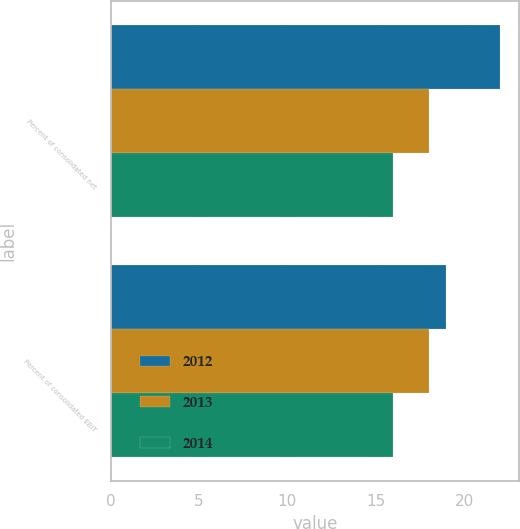<chart> <loc_0><loc_0><loc_500><loc_500><stacked_bar_chart><ecel><fcel>Percent of consolidated net<fcel>Percent of consolidated EBIT<nl><fcel>2012<fcel>22<fcel>19<nl><fcel>2013<fcel>18<fcel>18<nl><fcel>2014<fcel>16<fcel>16<nl></chart> 